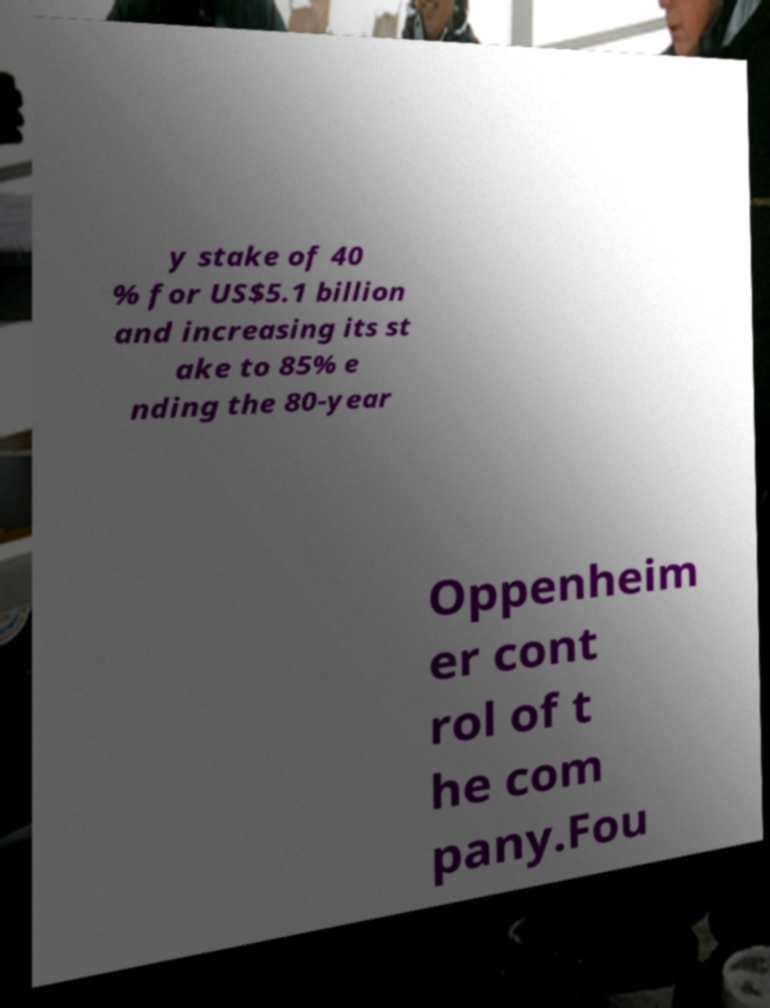There's text embedded in this image that I need extracted. Can you transcribe it verbatim? y stake of 40 % for US$5.1 billion and increasing its st ake to 85% e nding the 80-year Oppenheim er cont rol of t he com pany.Fou 